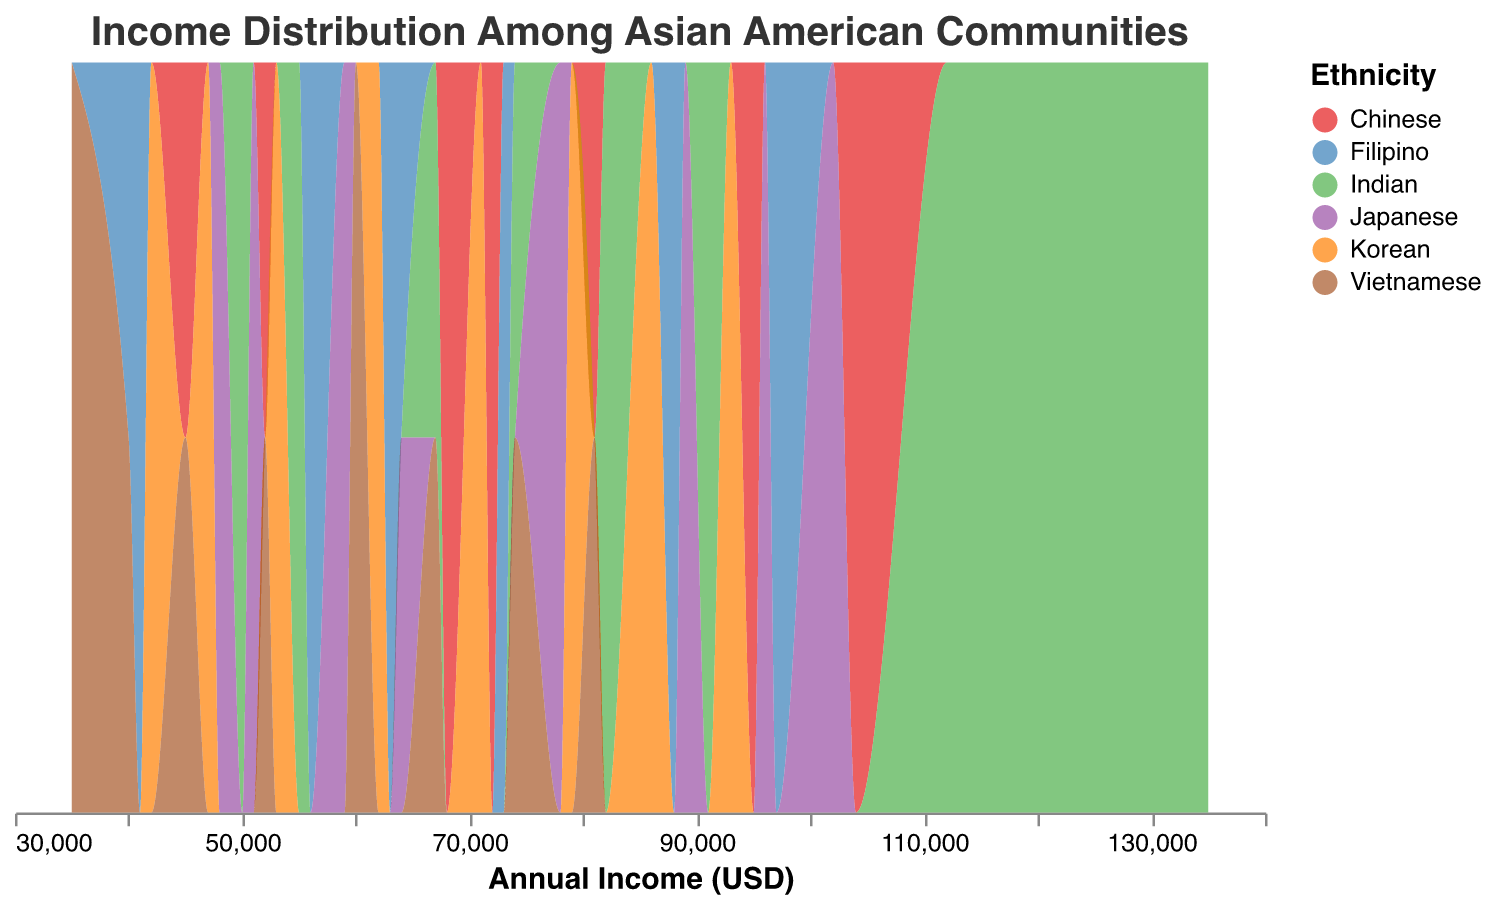What is the title of the density plot? The title is usually displayed at the top of the figure. For this figure, the title is directly mentioned just above the plot.
Answer: Income Distribution Among Asian American Communities What are the x-axis and y-axis labels? The x-axis corresponds to "Annual Income (USD)," and this is mentioned in the code under "x": { "title": "Annual Income (USD)"}. The y-axis is not explicitly labeled as its axis is null in the code, meaning it's likely a normalized count of the density distribution.
Answer: Annual Income (USD) and none Which ethnic group has the highest peak density in the plot? By comparing the density curves for each ethnic group, the group with the curve that reaches the highest normalized value on the y-axis has the highest peak density. Without the plot, assume one of the colors or legends represented has the highest peak.
Answer: [Based on the plot's visual indication] Which income level has the highest density for Indian Americans? Examination of the density plot requires looking at where the "Indian" curve on the x-axis for `Income` has the highest y-value.
Answer: [Based on the plot's visual indication] What is the range of the income levels considered in this plot? The x-axis domain sets limits between 30,000 to 140,000 USD which represent the income levels accounted for in the density plot.
Answer: 30,000 to 140,000 USD Among Chinese and Vietnamese, which group has a higher density in the middle-income range (50,000 - 70,000 USD)? Review the segments of the density curves for both groups within the specified income range. Compare their y-values, where a higher value represents a higher density.
Answer: [Based on the plot's visual indication] What does a higher peak in a density plot indicate about the income distribution for a particular ethnic group? A higher peak indicates a higher concentration or frequency of individuals within that income level for that group. Examine the plot where there are multiple peaks at specific incomes for understanding variations.
Answer: Higher frequency at that income level Which ethnic group appears to have the widest spread in income distribution? Look at the ethnic group's density curve that stretches the furthest along the x-axis with significant values. The group with the most spread from the left to right indicates the widest income distribution.
Answer: [Based on the plot's visual indication] How do the income levels of Korean Americans compare to those of Filipino Americans? Compare the normalized density curves of Korean and Filipino Americans; look at how the curves overlap or diverge, indicating different concentrations at same or differing income levels.
Answer: [Based on the plot's visual indication] What does it mean for groups' income densities to "stack" in this context? The normalized stacking means comparing the distributions directly within the same plot, stacked for proportions without distortion via direct count visualization. This shows relative density in proportion to total density across different groups.
Answer: Relative density comparison 